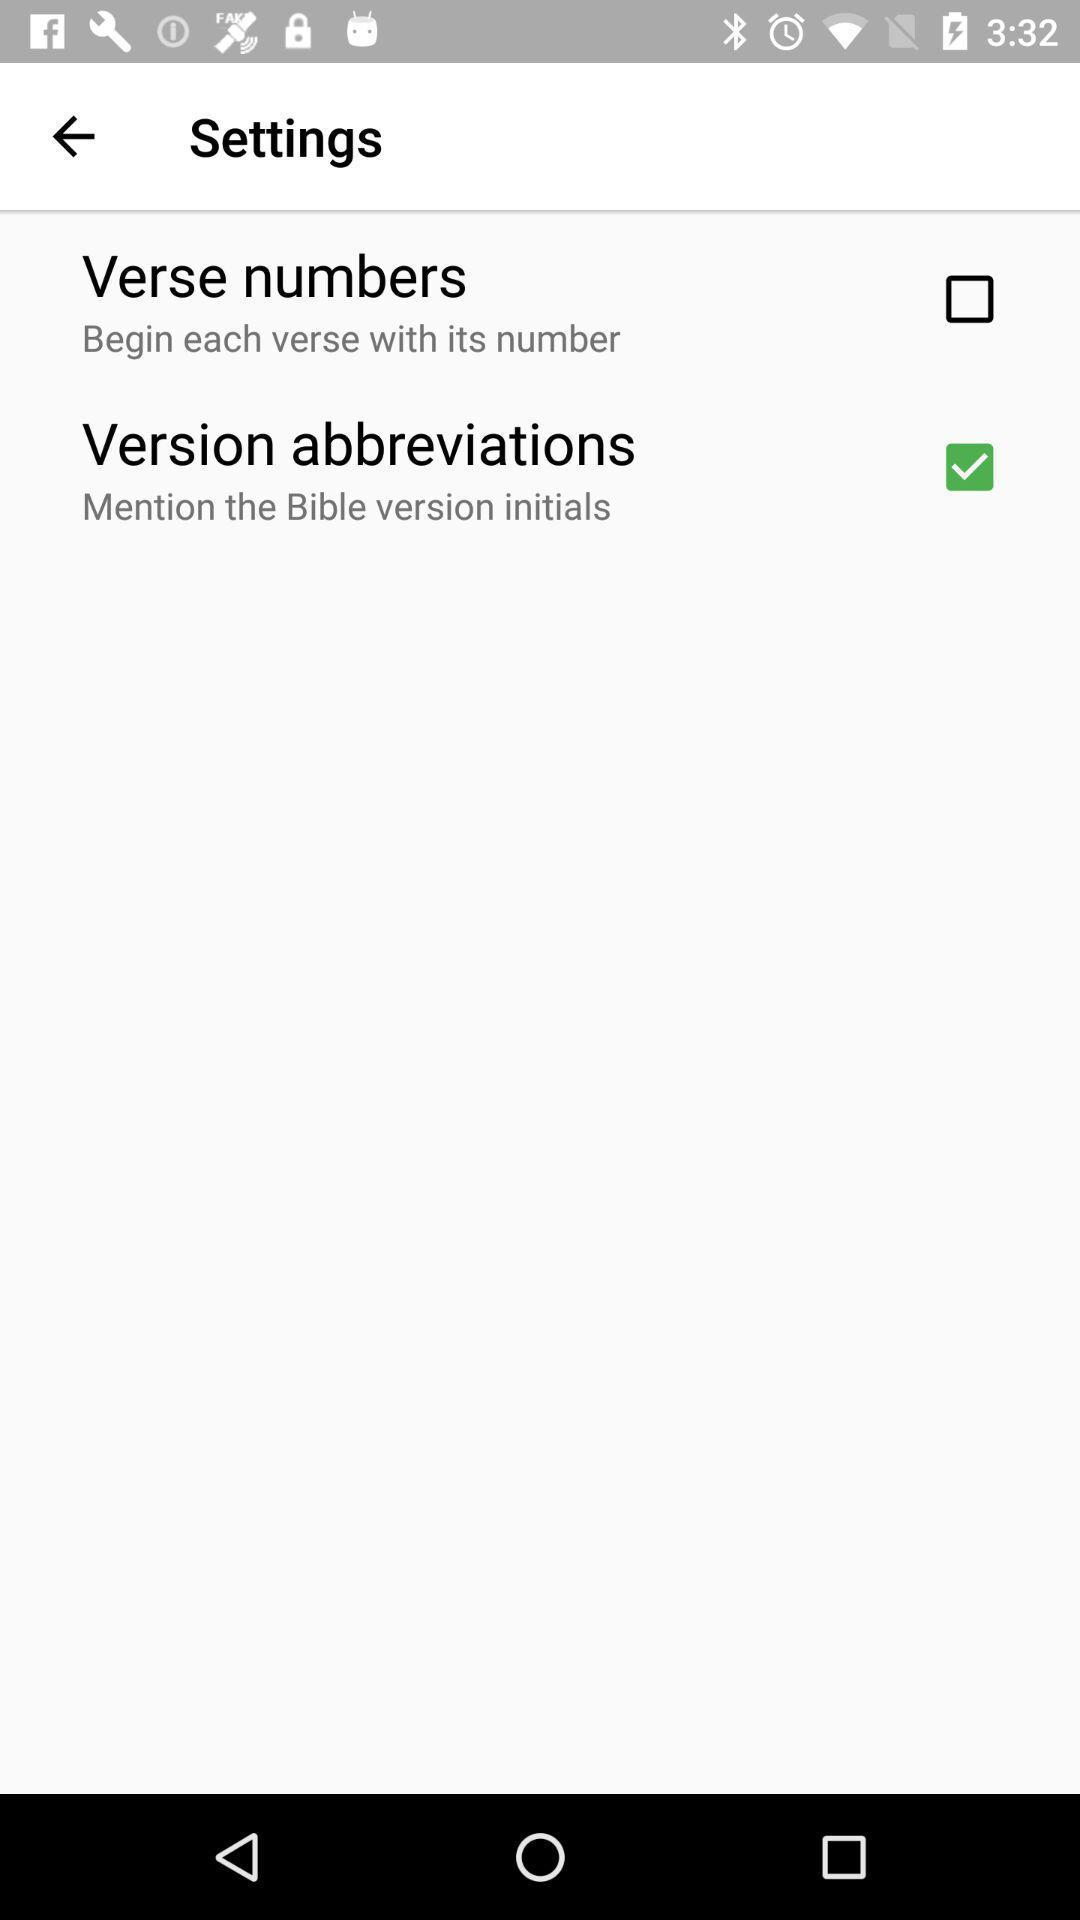Which option is not checked marked? The option that is not checked marked is "Verse numbers". 